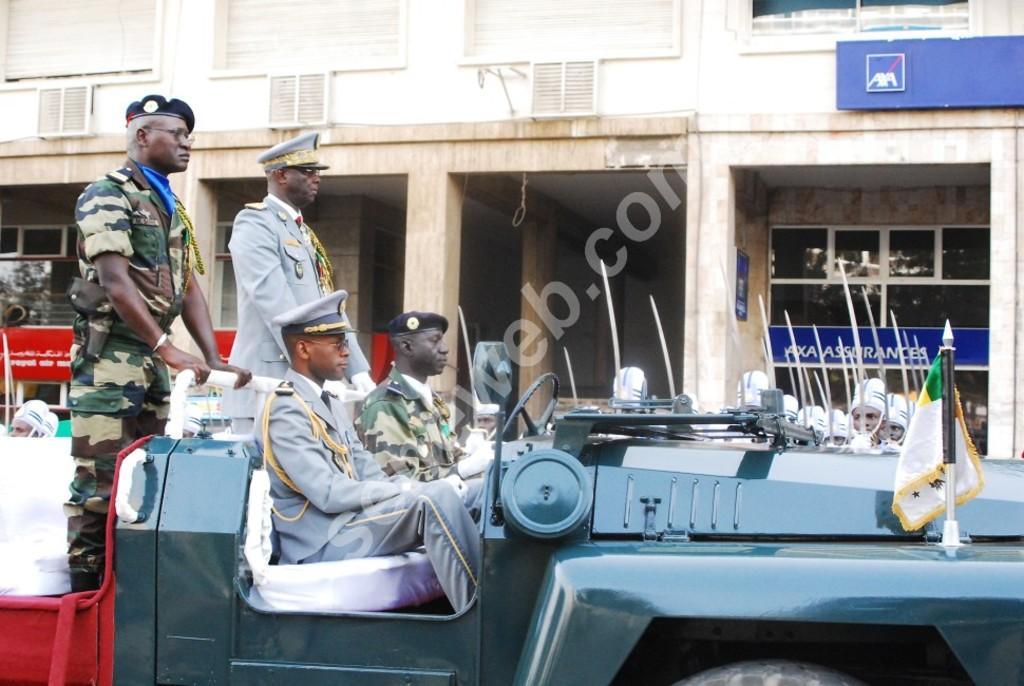In one or two sentences, can you explain what this image depicts? In the picture we can see a army vehicle which is blue in color with a flag on it and two army people are sitting near the steering and two people are standing at the back in the vehicle and beside the vehicle we can see some people standing in the uniforms holding swords near the building. 